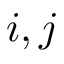Convert formula to latex. <formula><loc_0><loc_0><loc_500><loc_500>i , j</formula> 